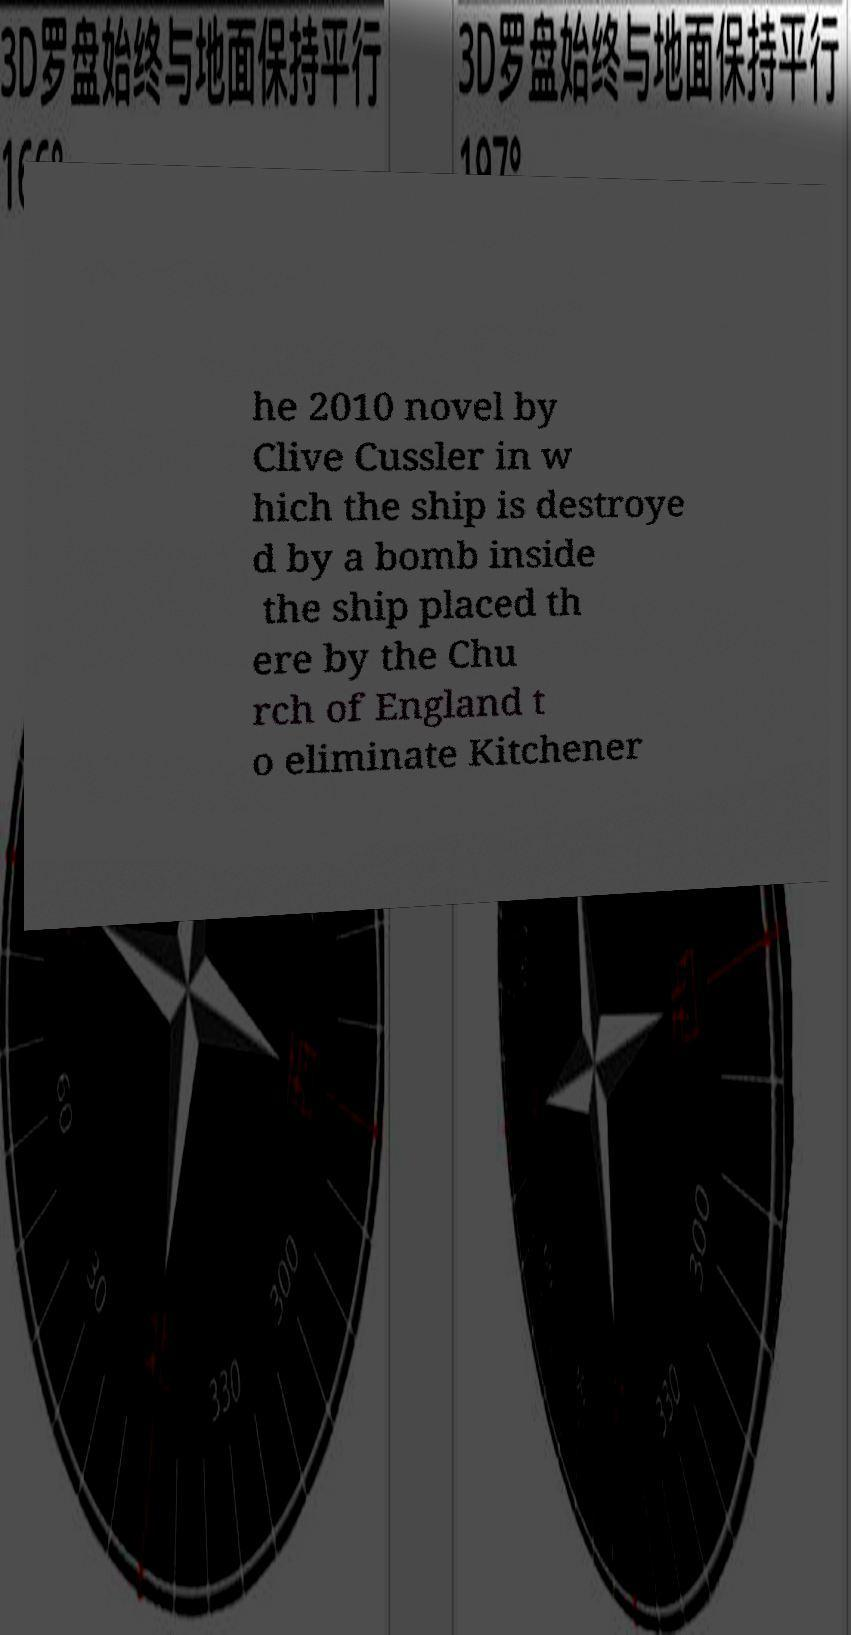Could you extract and type out the text from this image? he 2010 novel by Clive Cussler in w hich the ship is destroye d by a bomb inside the ship placed th ere by the Chu rch of England t o eliminate Kitchener 